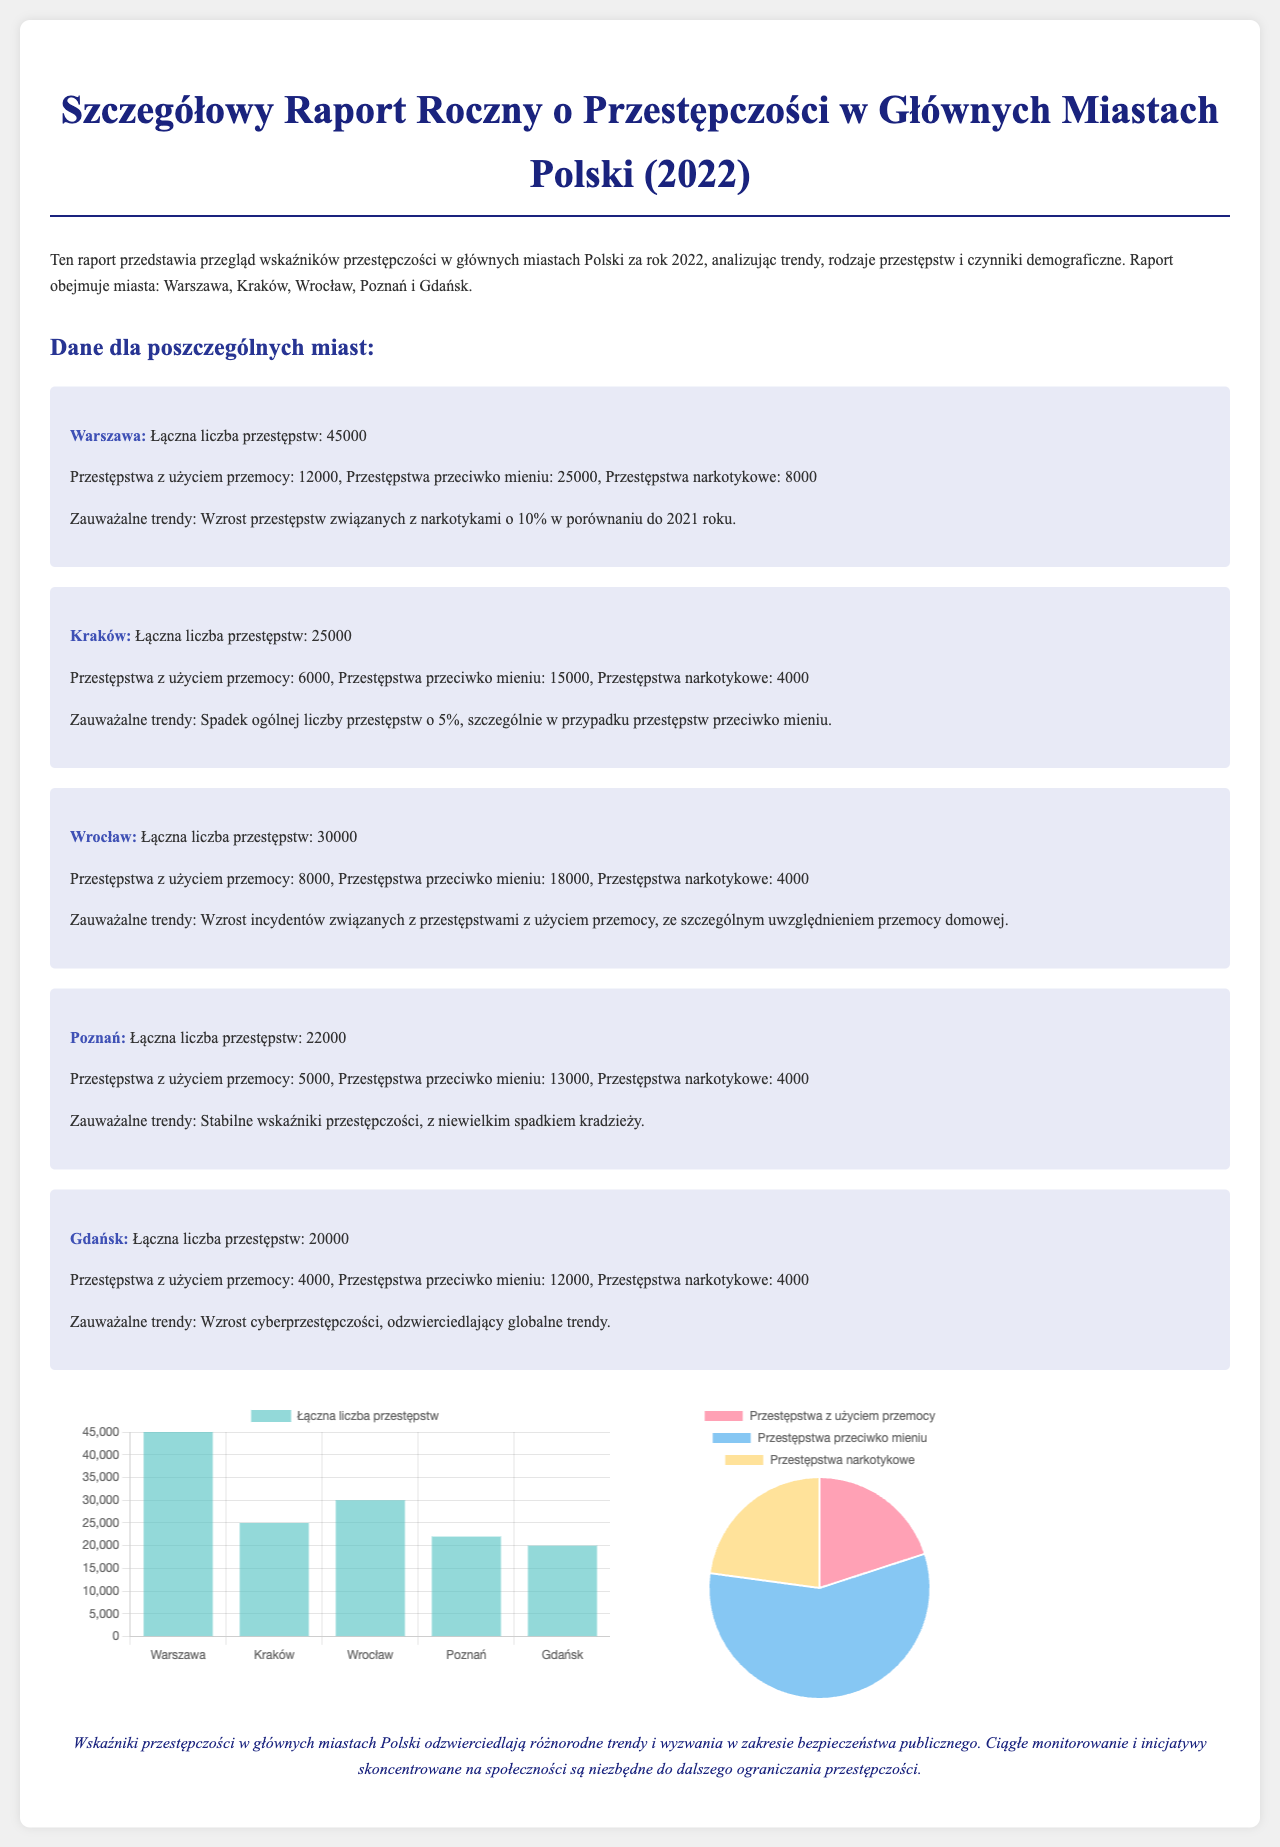What is the total number of crimes in Warsaw? The total number of crimes in Warsaw is explicitly stated in the document as 45000.
Answer: 45000 What is the percentage increase in drug-related crimes in Warsaw compared to 2021? The document notes a 10% increase in drug-related crimes in Warsaw compared to the previous year.
Answer: 10% Which city has the highest number of violent crimes? The city with the highest number of violent crimes is Warsaw, which reported 12000 such incidents.
Answer: Warsaw What trend is observed in Kraków regarding property crimes? The document indicates a decrease in property crimes in Kraków, specifying a 5% decline overall.
Answer: Decrease What is the total number of violent crimes reported in Gdańsk? The total number of violent crimes reported in Gdańsk is explicitly mentioned as 4000.
Answer: 4000 Which city experienced an increase in domestic violence incidents? The document highlights an increase in incidents of domestic violence specifically in Wrocław.
Answer: Wrocław How many crimes were reported in Poznań? The document states that Poznań reported a total of 22000 crimes during the year 2022.
Answer: 22000 What type of crime is on the rise in Gdańsk? The document points out that cybercrime is on the rise in Gdańsk, reflecting a global trend.
Answer: Cybercrime 